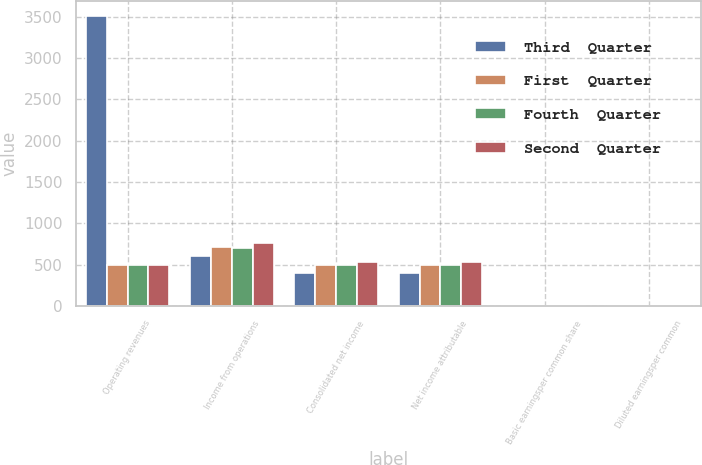Convert chart. <chart><loc_0><loc_0><loc_500><loc_500><stacked_bar_chart><ecel><fcel>Operating revenues<fcel>Income from operations<fcel>Consolidated net income<fcel>Net income attributable<fcel>Basic earningsper common share<fcel>Diluted earningsper common<nl><fcel>Third  Quarter<fcel>3511<fcel>608<fcel>395<fcel>396<fcel>0.91<fcel>0.91<nl><fcel>First  Quarter<fcel>498<fcel>715<fcel>499<fcel>499<fcel>1.16<fcel>1.15<nl><fcel>Fourth  Quarter<fcel>498<fcel>699<fcel>498<fcel>499<fcel>1.16<fcel>1.16<nl><fcel>Second  Quarter<fcel>498<fcel>767<fcel>531<fcel>531<fcel>1.25<fcel>1.24<nl></chart> 